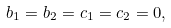<formula> <loc_0><loc_0><loc_500><loc_500>b _ { 1 } = b _ { 2 } = c _ { 1 } = c _ { 2 } = 0 ,</formula> 